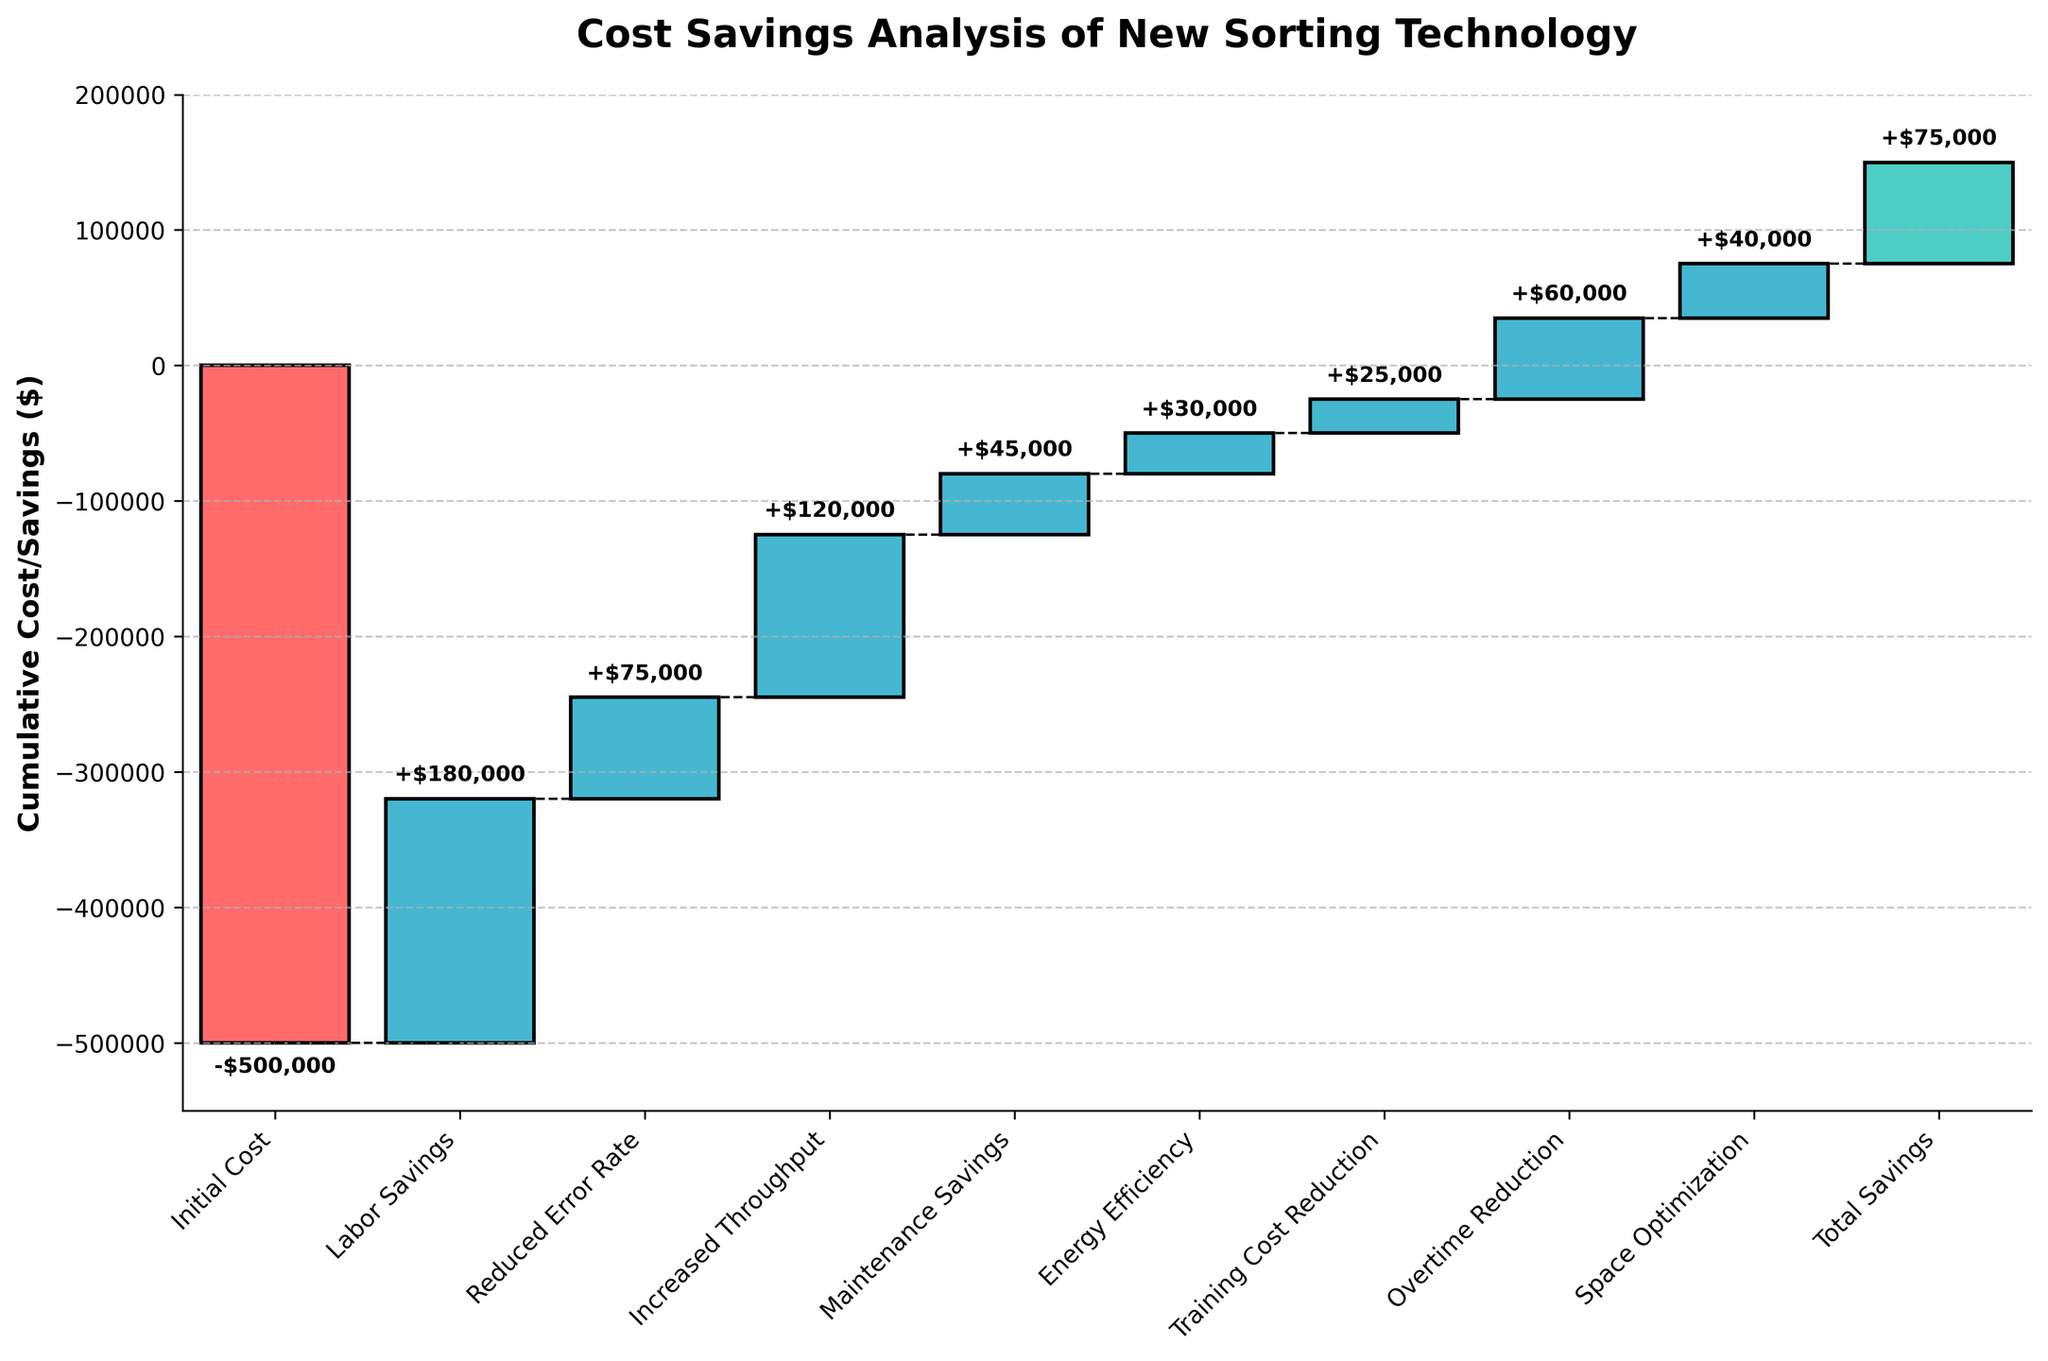What is the title of the chart? The title of the chart is usually located at the top, and in this case, it's designed to describe the main purpose of the chart.
Answer: Cost Savings Analysis of New Sorting Technology How many categories are represented in the chart? To determine the number of categories, count the labels on the x-axis. Each label represents a distinct category.
Answer: 10 What is the initial cost of implementing the new sorting technology? The initial cost is represented by the first bar on the waterfall chart. The tooltip or label on the bar shows the exact value.
Answer: -$500,000 Which category contributes the most to the savings? To find the category with the highest positive value, compare the heights of the positively colored bars. The bar with the highest positive value represents the largest contribution to savings.
Answer: Labor Savings By how much does the reduced error rate improve the savings? Locate the bar labeled "Reduced Error Rate" and read its corresponding savings value directly from the tooltip or the label on the bar.
Answer: $75,000 What is the total cumulative savings? The total cumulative savings are represented by the final bar in the waterfall chart. The tooltip or label on this bar shows the total cumulative savings value.
Answer: $75,000 How does maintenance savings compare to energy efficiency savings? Compare the heights of the bars labeled "Maintenance Savings" and "Energy Efficiency." The taller bar represents a higher savings amount.
Answer: Maintenance Savings is higher ($45,000 vs. $30,000) What is the combined savings from reduced error rate, increased throughput, and maintenance savings? Sum the savings values for "Reduced Error Rate" ($75,000), "Increased Throughput" ($120,000), and "Maintenance Savings" ($45,000).
Answer: $240,000 Which categories have a negative impact on the total savings? Identify the categories with bars extending downwards (negative values). These categories represent costs rather than savings.
Answer: Initial Cost What is the difference between labor savings and overtime reduction? Subtract the value of "Overtime Reduction" from "Labor Savings" to find the difference.
Answer: $120,000 (Labor Savings $180,000 - Overtime Reduction $60,000) 